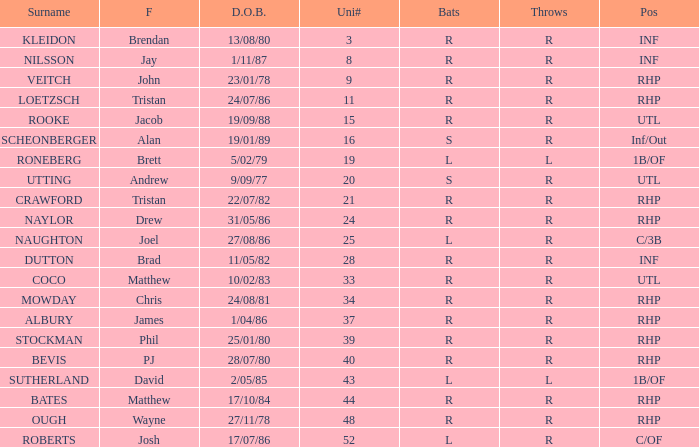Which Uni # has a Surname of ough? 48.0. Could you help me parse every detail presented in this table? {'header': ['Surname', 'F', 'D.O.B.', 'Uni#', 'Bats', 'Throws', 'Pos'], 'rows': [['KLEIDON', 'Brendan', '13/08/80', '3', 'R', 'R', 'INF'], ['NILSSON', 'Jay', '1/11/87', '8', 'R', 'R', 'INF'], ['VEITCH', 'John', '23/01/78', '9', 'R', 'R', 'RHP'], ['LOETZSCH', 'Tristan', '24/07/86', '11', 'R', 'R', 'RHP'], ['ROOKE', 'Jacob', '19/09/88', '15', 'R', 'R', 'UTL'], ['SCHEONBERGER', 'Alan', '19/01/89', '16', 'S', 'R', 'Inf/Out'], ['RONEBERG', 'Brett', '5/02/79', '19', 'L', 'L', '1B/OF'], ['UTTING', 'Andrew', '9/09/77', '20', 'S', 'R', 'UTL'], ['CRAWFORD', 'Tristan', '22/07/82', '21', 'R', 'R', 'RHP'], ['NAYLOR', 'Drew', '31/05/86', '24', 'R', 'R', 'RHP'], ['NAUGHTON', 'Joel', '27/08/86', '25', 'L', 'R', 'C/3B'], ['DUTTON', 'Brad', '11/05/82', '28', 'R', 'R', 'INF'], ['COCO', 'Matthew', '10/02/83', '33', 'R', 'R', 'UTL'], ['MOWDAY', 'Chris', '24/08/81', '34', 'R', 'R', 'RHP'], ['ALBURY', 'James', '1/04/86', '37', 'R', 'R', 'RHP'], ['STOCKMAN', 'Phil', '25/01/80', '39', 'R', 'R', 'RHP'], ['BEVIS', 'PJ', '28/07/80', '40', 'R', 'R', 'RHP'], ['SUTHERLAND', 'David', '2/05/85', '43', 'L', 'L', '1B/OF'], ['BATES', 'Matthew', '17/10/84', '44', 'R', 'R', 'RHP'], ['OUGH', 'Wayne', '27/11/78', '48', 'R', 'R', 'RHP'], ['ROBERTS', 'Josh', '17/07/86', '52', 'L', 'R', 'C/OF']]} 